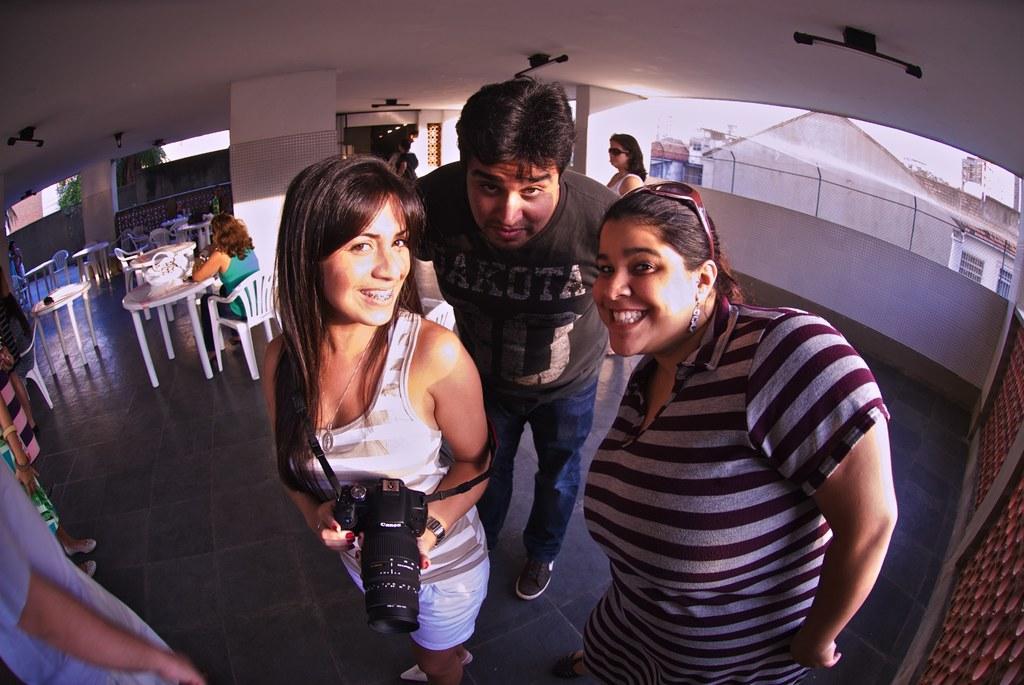Could you give a brief overview of what you see in this image? Here we see a man and two women Standing with a smile on their faces. a woman holds a camera in her hand and we see few tables chairs. 